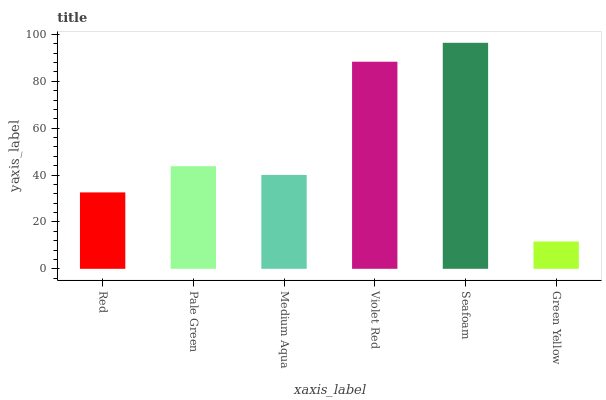Is Green Yellow the minimum?
Answer yes or no. Yes. Is Seafoam the maximum?
Answer yes or no. Yes. Is Pale Green the minimum?
Answer yes or no. No. Is Pale Green the maximum?
Answer yes or no. No. Is Pale Green greater than Red?
Answer yes or no. Yes. Is Red less than Pale Green?
Answer yes or no. Yes. Is Red greater than Pale Green?
Answer yes or no. No. Is Pale Green less than Red?
Answer yes or no. No. Is Pale Green the high median?
Answer yes or no. Yes. Is Medium Aqua the low median?
Answer yes or no. Yes. Is Medium Aqua the high median?
Answer yes or no. No. Is Violet Red the low median?
Answer yes or no. No. 